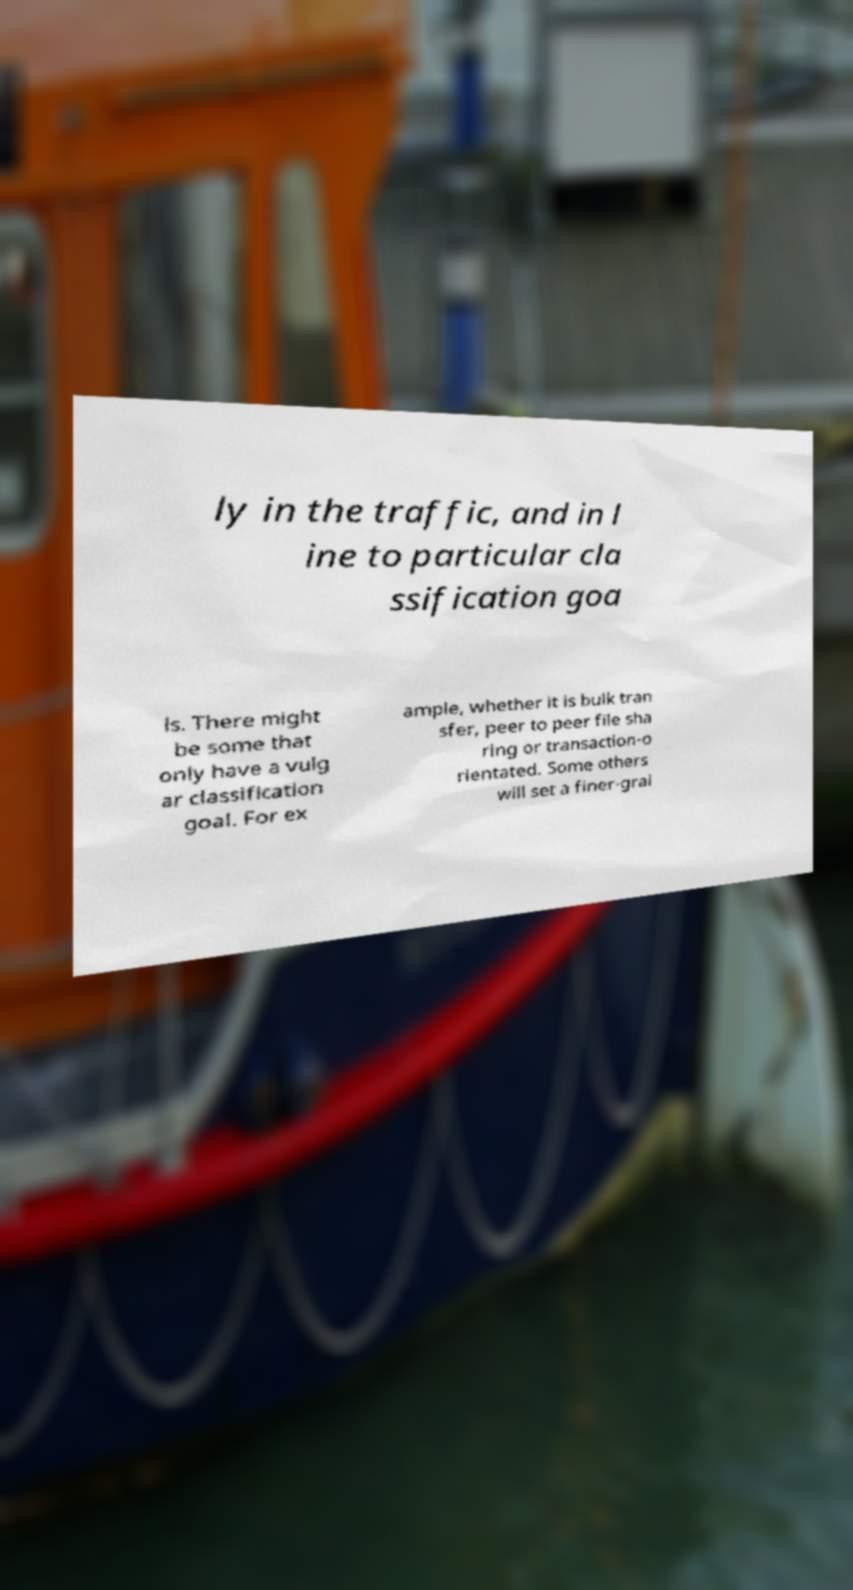Can you read and provide the text displayed in the image?This photo seems to have some interesting text. Can you extract and type it out for me? ly in the traffic, and in l ine to particular cla ssification goa ls. There might be some that only have a vulg ar classification goal. For ex ample, whether it is bulk tran sfer, peer to peer file sha ring or transaction-o rientated. Some others will set a finer-grai 